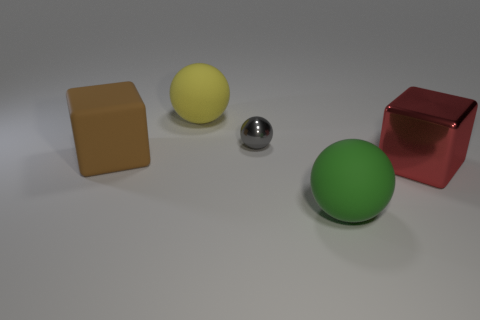What number of large rubber things are behind the cube that is right of the small metallic sphere?
Provide a short and direct response. 2. There is a yellow thing; does it have the same size as the matte ball that is to the right of the gray shiny object?
Give a very brief answer. Yes. Is there another object of the same color as the large metal object?
Provide a succinct answer. No. The other object that is made of the same material as the red thing is what size?
Your answer should be compact. Small. Do the big green sphere and the small gray ball have the same material?
Ensure brevity in your answer.  No. What color is the big ball that is right of the matte sphere to the left of the matte ball that is in front of the gray object?
Provide a succinct answer. Green. The yellow rubber thing has what shape?
Ensure brevity in your answer.  Sphere. Do the matte block and the big object that is on the right side of the big green sphere have the same color?
Offer a terse response. No. Are there an equal number of green rubber spheres on the left side of the gray shiny object and red objects?
Your response must be concise. No. What number of brown rubber objects are the same size as the green sphere?
Your answer should be compact. 1. 